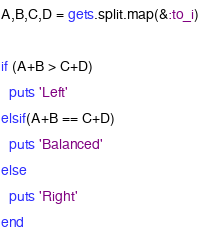<code> <loc_0><loc_0><loc_500><loc_500><_Ruby_>A,B,C,D = gets.split.map(&:to_i)

if (A+B > C+D)
  puts 'Left'
elsif(A+B == C+D)
  puts 'Balanced'
else
  puts 'Right'
end</code> 